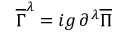<formula> <loc_0><loc_0><loc_500><loc_500>\overline { \Gamma } ^ { \lambda } = i g \, \partial ^ { \lambda } \overline { \Pi }</formula> 